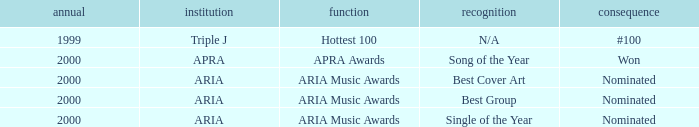Which award was nominated for in 2000? Best Cover Art, Best Group, Single of the Year. 